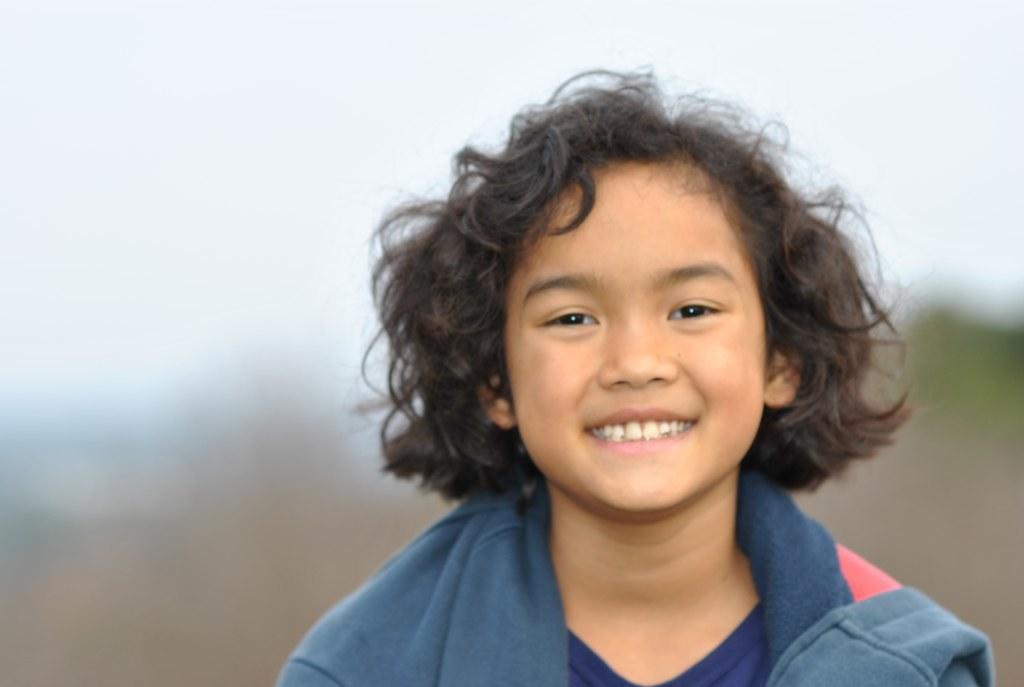In one or two sentences, can you explain what this image depicts? This image is taken outdoors. In this image the background is a little blurred. At the top of the image there is the sky. In the middle of the image there is a boy and he is with a smiling face. 